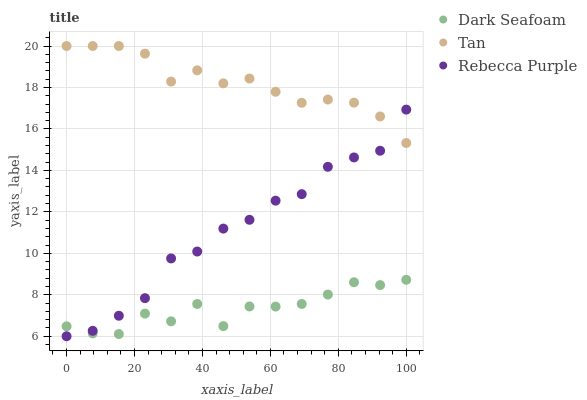Does Dark Seafoam have the minimum area under the curve?
Answer yes or no. Yes. Does Tan have the maximum area under the curve?
Answer yes or no. Yes. Does Rebecca Purple have the minimum area under the curve?
Answer yes or no. No. Does Rebecca Purple have the maximum area under the curve?
Answer yes or no. No. Is Tan the smoothest?
Answer yes or no. Yes. Is Dark Seafoam the roughest?
Answer yes or no. Yes. Is Rebecca Purple the smoothest?
Answer yes or no. No. Is Rebecca Purple the roughest?
Answer yes or no. No. Does Rebecca Purple have the lowest value?
Answer yes or no. Yes. Does Tan have the lowest value?
Answer yes or no. No. Does Tan have the highest value?
Answer yes or no. Yes. Does Rebecca Purple have the highest value?
Answer yes or no. No. Is Dark Seafoam less than Tan?
Answer yes or no. Yes. Is Tan greater than Dark Seafoam?
Answer yes or no. Yes. Does Rebecca Purple intersect Tan?
Answer yes or no. Yes. Is Rebecca Purple less than Tan?
Answer yes or no. No. Is Rebecca Purple greater than Tan?
Answer yes or no. No. Does Dark Seafoam intersect Tan?
Answer yes or no. No. 